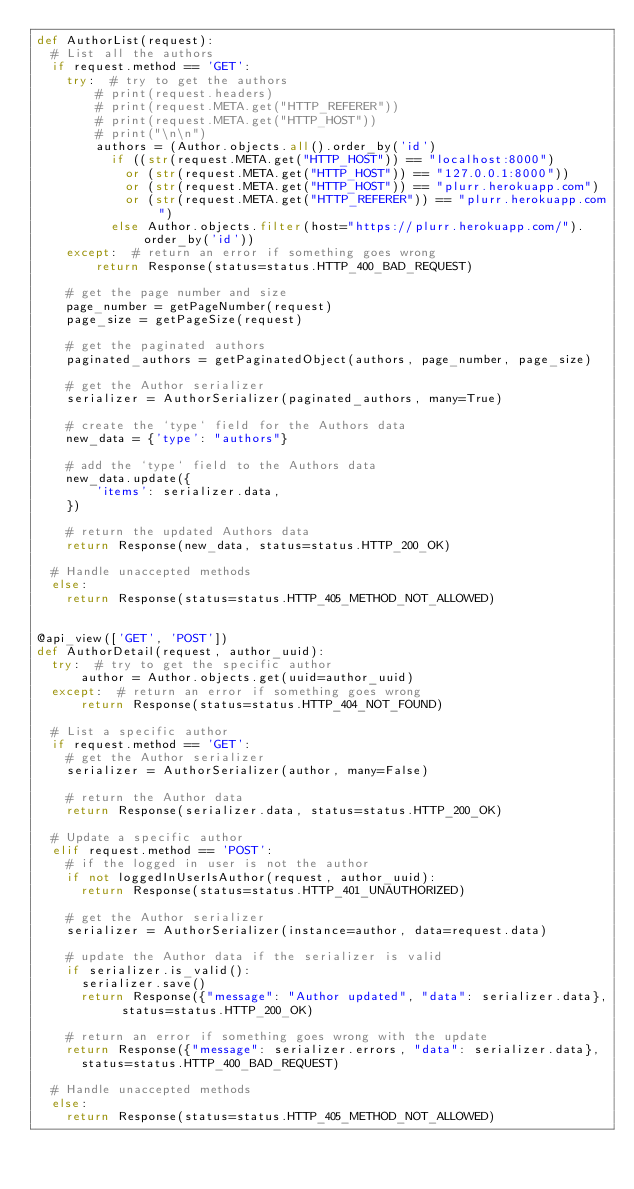<code> <loc_0><loc_0><loc_500><loc_500><_Python_>def AuthorList(request):
  # List all the authors
  if request.method == 'GET':
    try:  # try to get the authors
        # print(request.headers)
        # print(request.META.get("HTTP_REFERER"))
        # print(request.META.get("HTTP_HOST"))
        # print("\n\n")
        authors = (Author.objects.all().order_by('id') 
          if ((str(request.META.get("HTTP_HOST")) == "localhost:8000") 
            or (str(request.META.get("HTTP_HOST")) == "127.0.0.1:8000"))
            or (str(request.META.get("HTTP_HOST")) == "plurr.herokuapp.com")
            or (str(request.META.get("HTTP_REFERER")) == "plurr.herokuapp.com")
          else Author.objects.filter(host="https://plurr.herokuapp.com/").order_by('id'))
    except:  # return an error if something goes wrong
        return Response(status=status.HTTP_400_BAD_REQUEST)
    
    # get the page number and size
    page_number = getPageNumber(request)
    page_size = getPageSize(request)

    # get the paginated authors
    paginated_authors = getPaginatedObject(authors, page_number, page_size)

    # get the Author serializer
    serializer = AuthorSerializer(paginated_authors, many=True)

    # create the `type` field for the Authors data
    new_data = {'type': "authors"}

    # add the `type` field to the Authors data
    new_data.update({
        'items': serializer.data,
    })

    # return the updated Authors data
    return Response(new_data, status=status.HTTP_200_OK)

  # Handle unaccepted methods
  else:
    return Response(status=status.HTTP_405_METHOD_NOT_ALLOWED)


@api_view(['GET', 'POST'])
def AuthorDetail(request, author_uuid):
  try:  # try to get the specific author
      author = Author.objects.get(uuid=author_uuid)
  except:  # return an error if something goes wrong
      return Response(status=status.HTTP_404_NOT_FOUND)

  # List a specific author
  if request.method == 'GET':
    # get the Author serializer
    serializer = AuthorSerializer(author, many=False)

    # return the Author data
    return Response(serializer.data, status=status.HTTP_200_OK)

  # Update a specific author
  elif request.method == 'POST':
    # if the logged in user is not the author
    if not loggedInUserIsAuthor(request, author_uuid):  
      return Response(status=status.HTTP_401_UNAUTHORIZED)
    
    # get the Author serializer
    serializer = AuthorSerializer(instance=author, data=request.data)

    # update the Author data if the serializer is valid
    if serializer.is_valid():
      serializer.save()
      return Response({"message": "Author updated", "data": serializer.data}, status=status.HTTP_200_OK)

    # return an error if something goes wrong with the update
    return Response({"message": serializer.errors, "data": serializer.data}, 
      status=status.HTTP_400_BAD_REQUEST)

  # Handle unaccepted methods
  else:
    return Response(status=status.HTTP_405_METHOD_NOT_ALLOWED)
</code> 